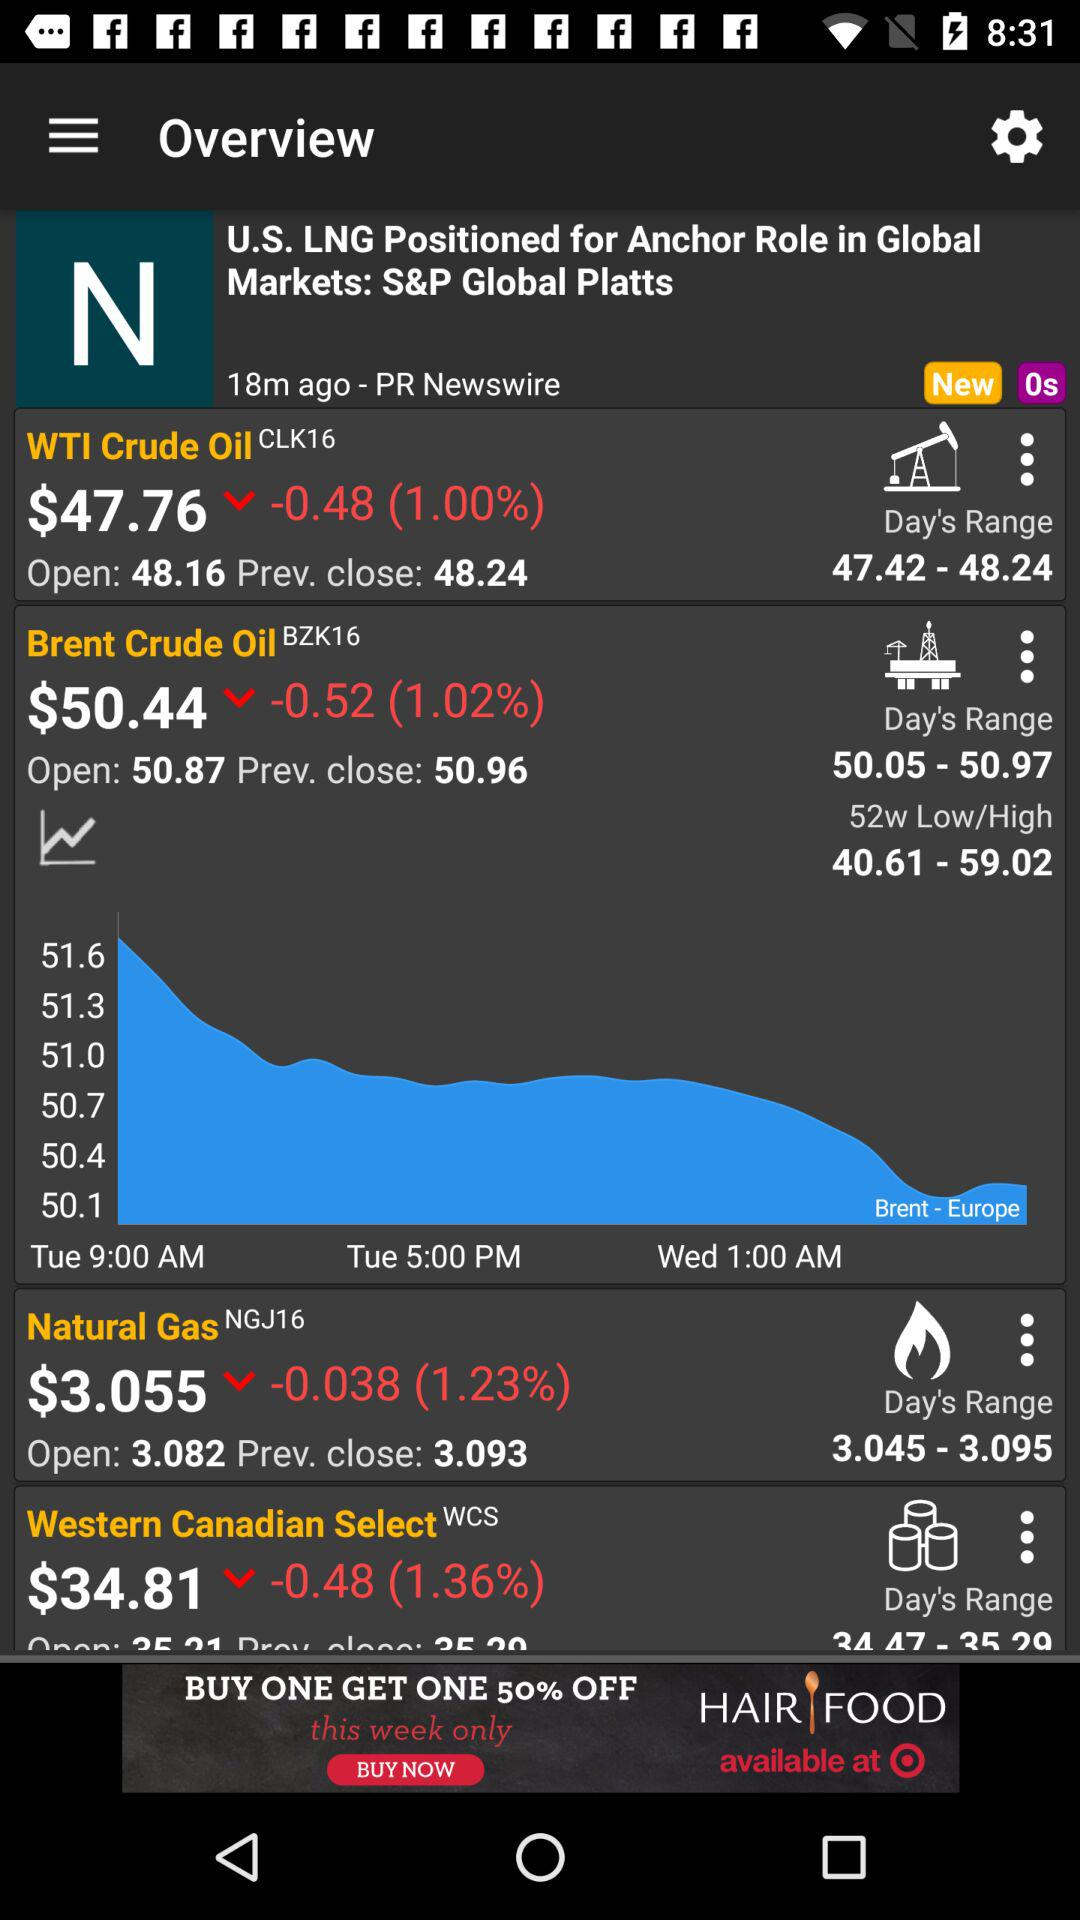What is the price of the "Brent Crude Oil" derivative? The price of the "Brent Crude Oil" derivative is $50.44. 